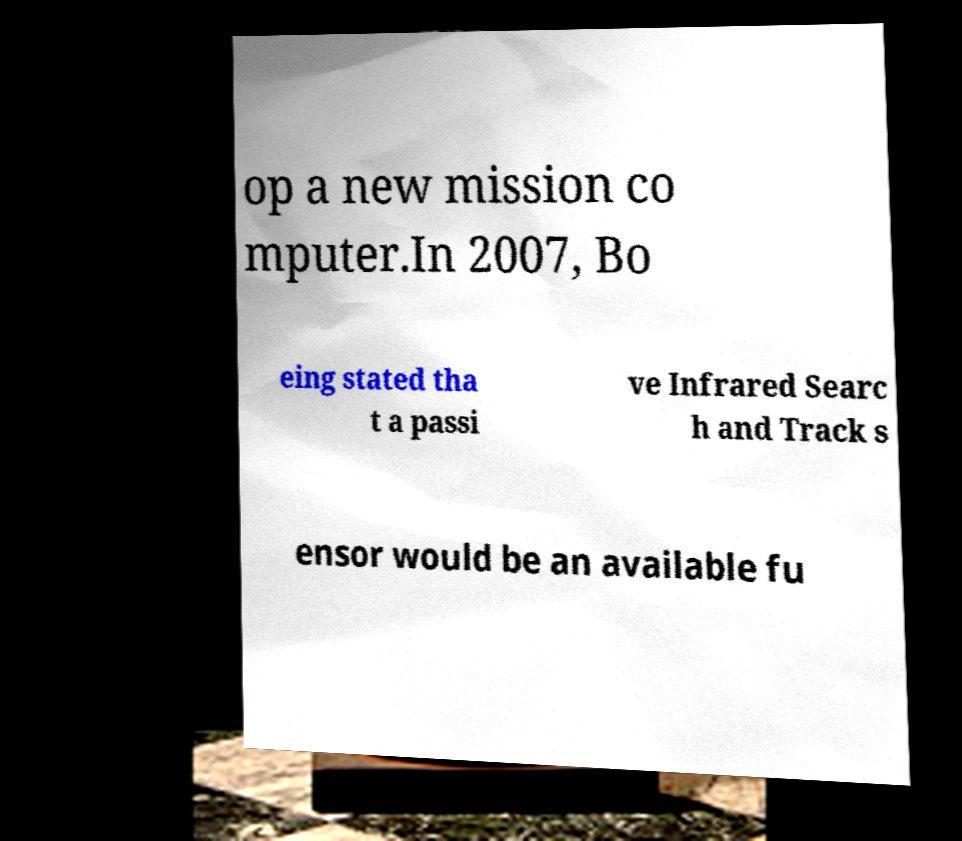Please read and relay the text visible in this image. What does it say? op a new mission co mputer.In 2007, Bo eing stated tha t a passi ve Infrared Searc h and Track s ensor would be an available fu 